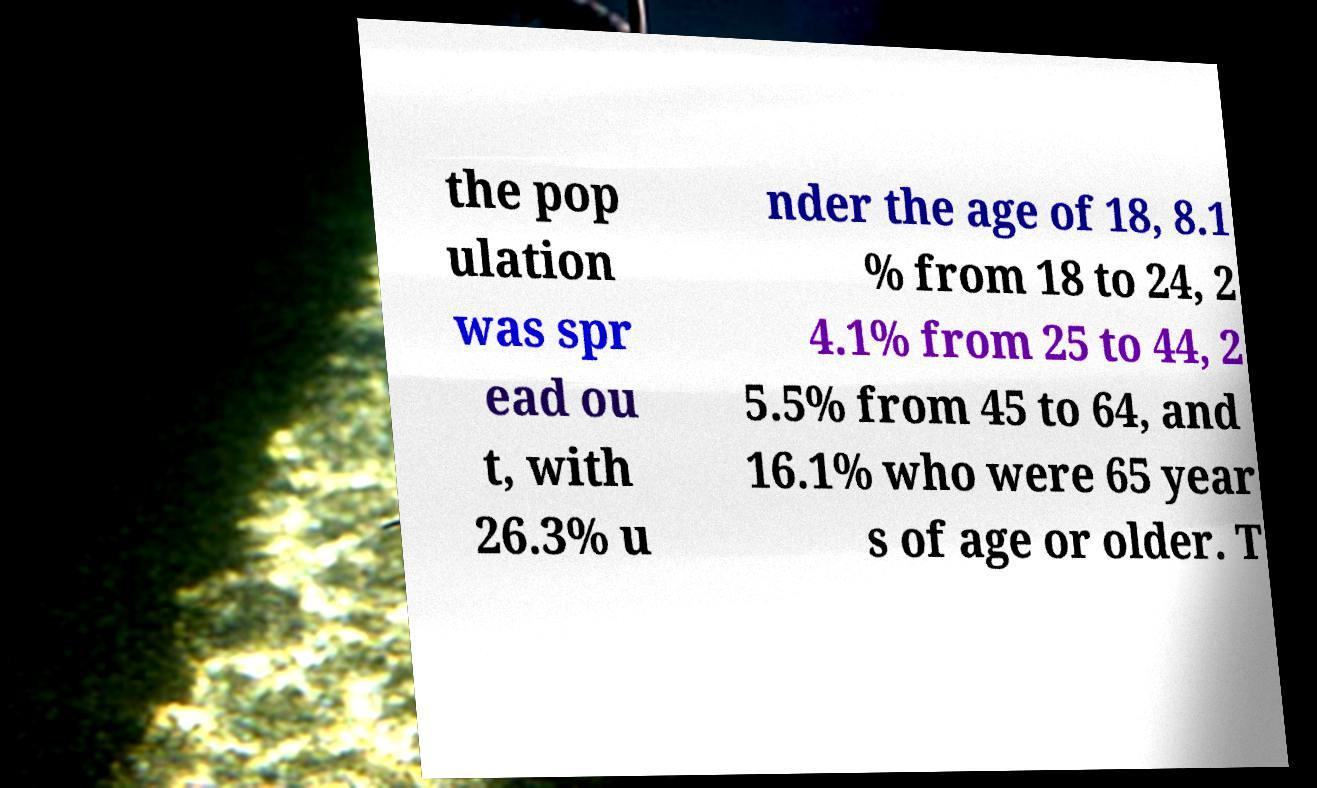Please identify and transcribe the text found in this image. the pop ulation was spr ead ou t, with 26.3% u nder the age of 18, 8.1 % from 18 to 24, 2 4.1% from 25 to 44, 2 5.5% from 45 to 64, and 16.1% who were 65 year s of age or older. T 